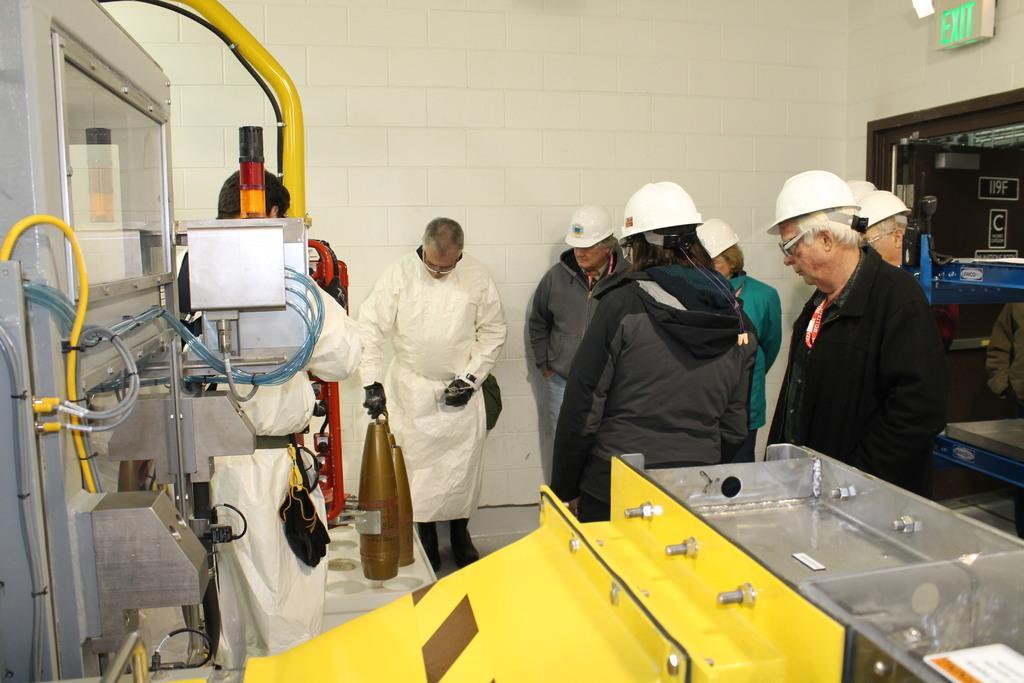How would you summarize this image in a sentence or two? In this image, I can see a group of people standing and there are machines. On the right side of the image, I can see a door and an exit board. In the background there is a wall. 